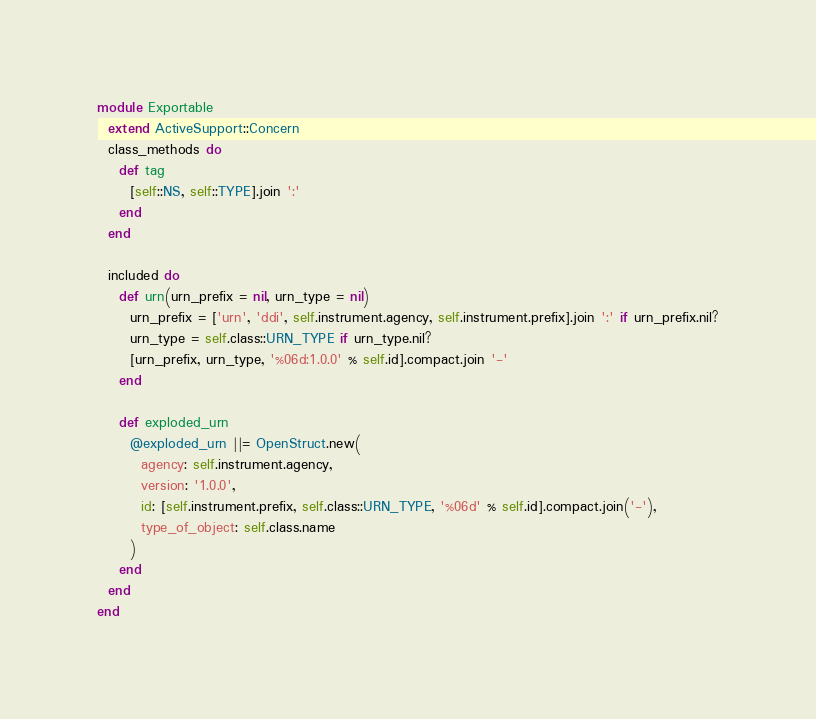Convert code to text. <code><loc_0><loc_0><loc_500><loc_500><_Ruby_>module Exportable
  extend ActiveSupport::Concern
  class_methods do
    def tag
      [self::NS, self::TYPE].join ':'
    end
  end

  included do
    def urn(urn_prefix = nil, urn_type = nil)
      urn_prefix = ['urn', 'ddi', self.instrument.agency, self.instrument.prefix].join ':' if urn_prefix.nil?
      urn_type = self.class::URN_TYPE if urn_type.nil?
      [urn_prefix, urn_type, '%06d:1.0.0' % self.id].compact.join '-'
    end

    def exploded_urn
      @exploded_urn ||= OpenStruct.new(
        agency: self.instrument.agency,
        version: '1.0.0',
        id: [self.instrument.prefix, self.class::URN_TYPE, '%06d' % self.id].compact.join('-'),
        type_of_object: self.class.name
      )
    end
  end
end
</code> 